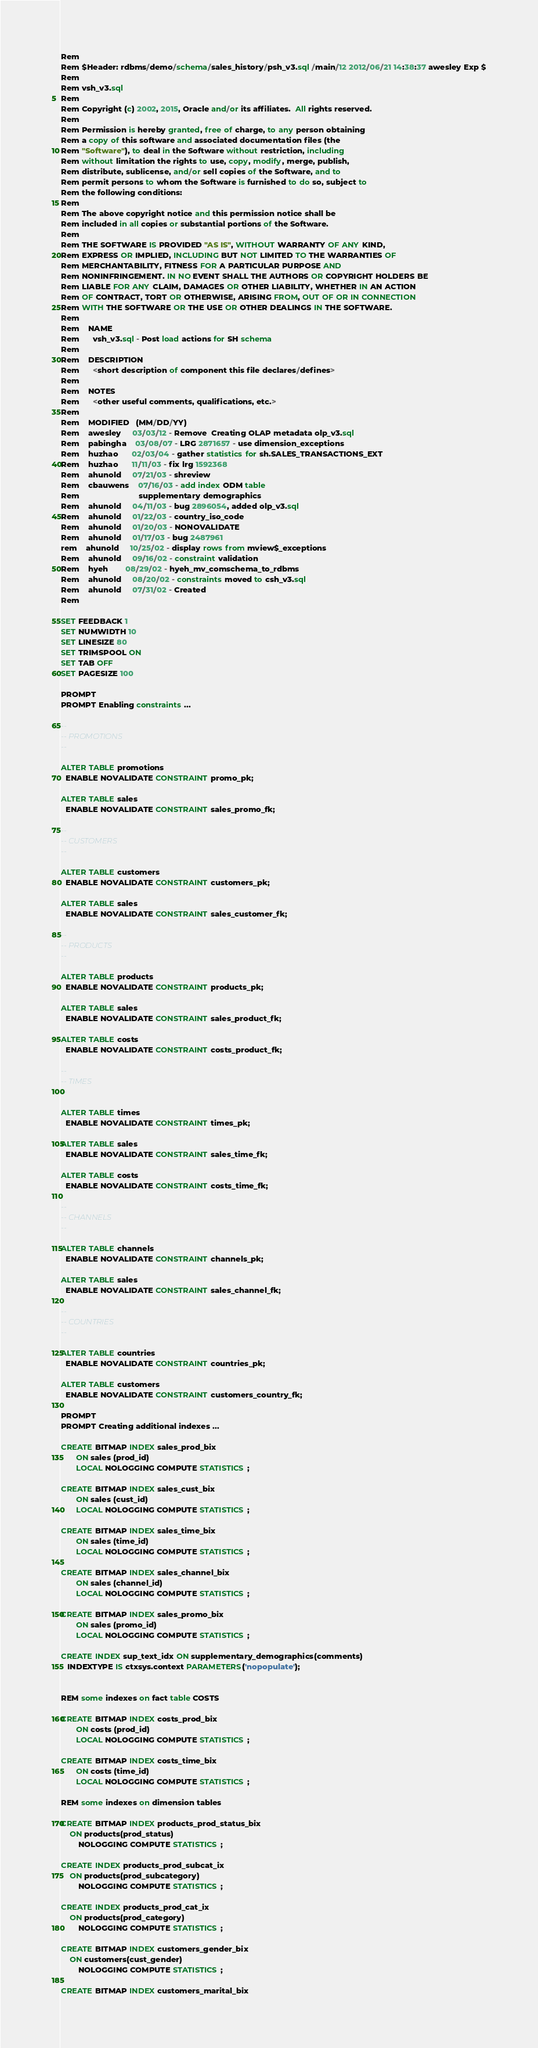<code> <loc_0><loc_0><loc_500><loc_500><_SQL_>Rem
Rem $Header: rdbms/demo/schema/sales_history/psh_v3.sql /main/12 2012/06/21 14:38:37 awesley Exp $
Rem
Rem vsh_v3.sql
Rem
Rem Copyright (c) 2002, 2015, Oracle and/or its affiliates.  All rights reserved. 
Rem 
Rem Permission is hereby granted, free of charge, to any person obtaining
Rem a copy of this software and associated documentation files (the
Rem "Software"), to deal in the Software without restriction, including
Rem without limitation the rights to use, copy, modify, merge, publish,
Rem distribute, sublicense, and/or sell copies of the Software, and to
Rem permit persons to whom the Software is furnished to do so, subject to
Rem the following conditions:
Rem 
Rem The above copyright notice and this permission notice shall be
Rem included in all copies or substantial portions of the Software.
Rem 
Rem THE SOFTWARE IS PROVIDED "AS IS", WITHOUT WARRANTY OF ANY KIND,
Rem EXPRESS OR IMPLIED, INCLUDING BUT NOT LIMITED TO THE WARRANTIES OF
Rem MERCHANTABILITY, FITNESS FOR A PARTICULAR PURPOSE AND
Rem NONINFRINGEMENT. IN NO EVENT SHALL THE AUTHORS OR COPYRIGHT HOLDERS BE
Rem LIABLE FOR ANY CLAIM, DAMAGES OR OTHER LIABILITY, WHETHER IN AN ACTION
Rem OF CONTRACT, TORT OR OTHERWISE, ARISING FROM, OUT OF OR IN CONNECTION
Rem WITH THE SOFTWARE OR THE USE OR OTHER DEALINGS IN THE SOFTWARE.
Rem
Rem    NAME
Rem      vsh_v3.sql - Post load actions for SH schema
Rem
Rem    DESCRIPTION
Rem      <short description of component this file declares/defines>
Rem
Rem    NOTES
Rem      <other useful comments, qualifications, etc.>
Rem
Rem    MODIFIED   (MM/DD/YY)
Rem    awesley     03/03/12 - Remove  Creating OLAP metadata olp_v3.sql
Rem    pabingha    03/08/07 - LRG 2871657 - use dimension_exceptions
Rem    huzhao      02/03/04 - gather statistics for sh.SALES_TRANSACTIONS_EXT 
Rem    huzhao      11/11/03 - fix lrg 1592368 
Rem    ahunold     07/21/03 - shreview
Rem    cbauwens    07/16/03 - add index ODM table
Rem                           supplementary demographics
Rem    ahunold     04/11/03 - bug 2896054, added olp_v3.sql
Rem    ahunold     01/22/03 - country_iso_code
Rem    ahunold     01/20/03 - NONOVALIDATE
Rem    ahunold     01/17/03 - bug 2487961
rem    ahunold     10/25/02 - display rows from mview$_exceptions
Rem    ahunold     09/16/02 - constraint validation
Rem    hyeh        08/29/02 - hyeh_mv_comschema_to_rdbms
Rem    ahunold     08/20/02 - constraints moved to csh_v3.sql
Rem    ahunold     07/31/02 - Created
Rem

SET FEEDBACK 1
SET NUMWIDTH 10
SET LINESIZE 80
SET TRIMSPOOL ON
SET TAB OFF
SET PAGESIZE 100

PROMPT
PROMPT Enabling constraints ...

--
-- PROMOTIONS
--

ALTER TABLE promotions
  ENABLE NOVALIDATE CONSTRAINT promo_pk;

ALTER TABLE sales
  ENABLE NOVALIDATE CONSTRAINT sales_promo_fk;

--
-- CUSTOMERS
--

ALTER TABLE customers
  ENABLE NOVALIDATE CONSTRAINT customers_pk;

ALTER TABLE sales
  ENABLE NOVALIDATE CONSTRAINT sales_customer_fk;

--
-- PRODUCTS
--

ALTER TABLE products
  ENABLE NOVALIDATE CONSTRAINT products_pk;

ALTER TABLE sales
  ENABLE NOVALIDATE CONSTRAINT sales_product_fk;

ALTER TABLE costs
  ENABLE NOVALIDATE CONSTRAINT costs_product_fk;

--
-- TIMES
--

ALTER TABLE times
  ENABLE NOVALIDATE CONSTRAINT times_pk;

ALTER TABLE sales
  ENABLE NOVALIDATE CONSTRAINT sales_time_fk;

ALTER TABLE costs
  ENABLE NOVALIDATE CONSTRAINT costs_time_fk;

--
-- CHANNELS
--

ALTER TABLE channels
  ENABLE NOVALIDATE CONSTRAINT channels_pk;

ALTER TABLE sales
  ENABLE NOVALIDATE CONSTRAINT sales_channel_fk;

--
-- COUNTRIES
--

ALTER TABLE countries
  ENABLE NOVALIDATE CONSTRAINT countries_pk;

ALTER TABLE customers
  ENABLE NOVALIDATE CONSTRAINT customers_country_fk;
  
PROMPT
PROMPT Creating additional indexes ...

CREATE BITMAP INDEX sales_prod_bix
       ON sales (prod_id)
       LOCAL NOLOGGING COMPUTE STATISTICS ;

CREATE BITMAP INDEX sales_cust_bix
       ON sales (cust_id)
       LOCAL NOLOGGING COMPUTE STATISTICS ;

CREATE BITMAP INDEX sales_time_bix
       ON sales (time_id)
       LOCAL NOLOGGING COMPUTE STATISTICS ;

CREATE BITMAP INDEX sales_channel_bix
       ON sales (channel_id)
       LOCAL NOLOGGING COMPUTE STATISTICS ;

CREATE BITMAP INDEX sales_promo_bix
       ON sales (promo_id)
       LOCAL NOLOGGING COMPUTE STATISTICS ;

CREATE INDEX sup_text_idx ON supplementary_demographics(comments)
   INDEXTYPE IS ctxsys.context PARAMETERS('nopopulate');


REM some indexes on fact table COSTS

CREATE BITMAP INDEX costs_prod_bix
       ON costs (prod_id)
       LOCAL NOLOGGING COMPUTE STATISTICS ;

CREATE BITMAP INDEX costs_time_bix
       ON costs (time_id)
       LOCAL NOLOGGING COMPUTE STATISTICS ;

REM some indexes on dimension tables

CREATE BITMAP INDEX products_prod_status_bix
	ON products(prod_status)
        NOLOGGING COMPUTE STATISTICS ;

CREATE INDEX products_prod_subcat_ix
	ON products(prod_subcategory)
        NOLOGGING COMPUTE STATISTICS ;

CREATE INDEX products_prod_cat_ix
	ON products(prod_category)
        NOLOGGING COMPUTE STATISTICS ;

CREATE BITMAP INDEX customers_gender_bix
	ON customers(cust_gender)
        NOLOGGING COMPUTE STATISTICS ;

CREATE BITMAP INDEX customers_marital_bix</code> 